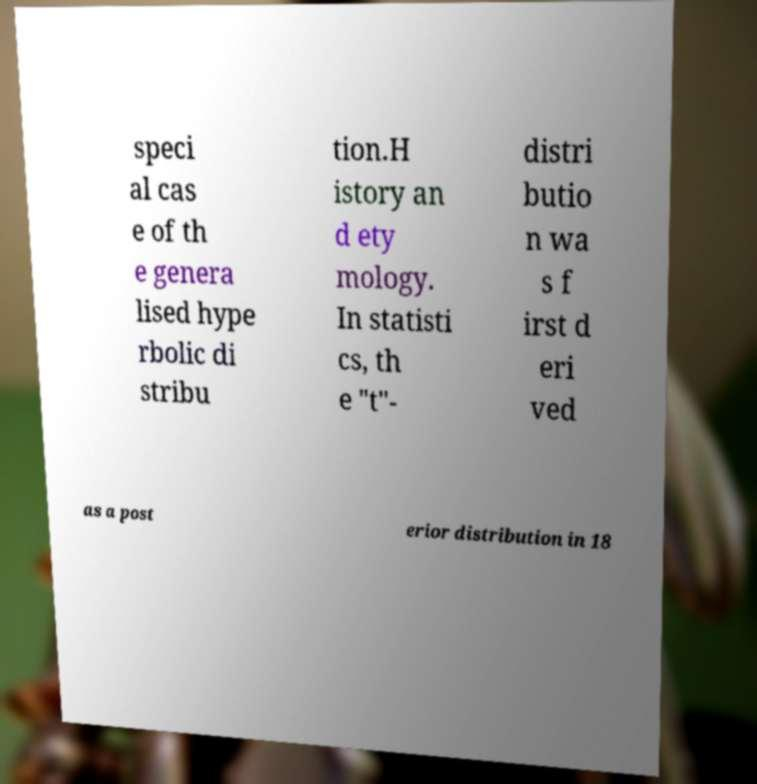Please identify and transcribe the text found in this image. speci al cas e of th e genera lised hype rbolic di stribu tion.H istory an d ety mology. In statisti cs, th e "t"- distri butio n wa s f irst d eri ved as a post erior distribution in 18 